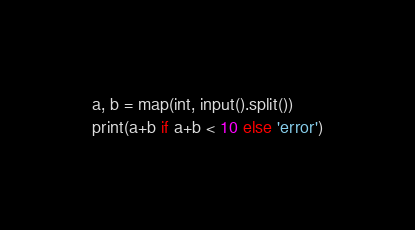<code> <loc_0><loc_0><loc_500><loc_500><_Python_>a, b = map(int, input().split())
print(a+b if a+b < 10 else 'error')</code> 